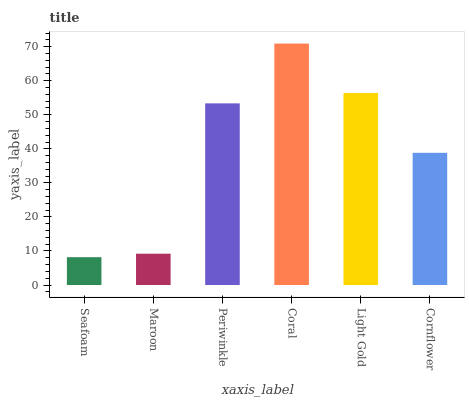Is Seafoam the minimum?
Answer yes or no. Yes. Is Coral the maximum?
Answer yes or no. Yes. Is Maroon the minimum?
Answer yes or no. No. Is Maroon the maximum?
Answer yes or no. No. Is Maroon greater than Seafoam?
Answer yes or no. Yes. Is Seafoam less than Maroon?
Answer yes or no. Yes. Is Seafoam greater than Maroon?
Answer yes or no. No. Is Maroon less than Seafoam?
Answer yes or no. No. Is Periwinkle the high median?
Answer yes or no. Yes. Is Cornflower the low median?
Answer yes or no. Yes. Is Seafoam the high median?
Answer yes or no. No. Is Light Gold the low median?
Answer yes or no. No. 